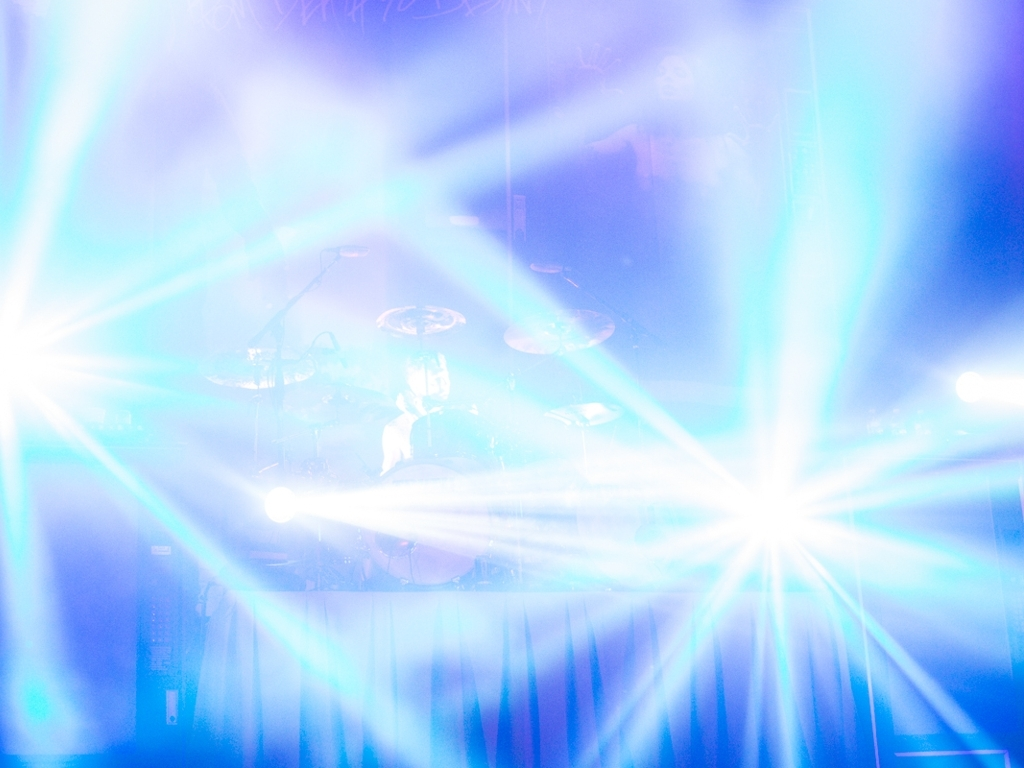Is it easy to see everything clearly in the image? Given the intense brightness and flare effect from the spotlights, it's not easy to make out the details in the image. The high exposure results in an over-saturated photo, where specific elements, such as a person who appears to be playing the drums, become obscured. 